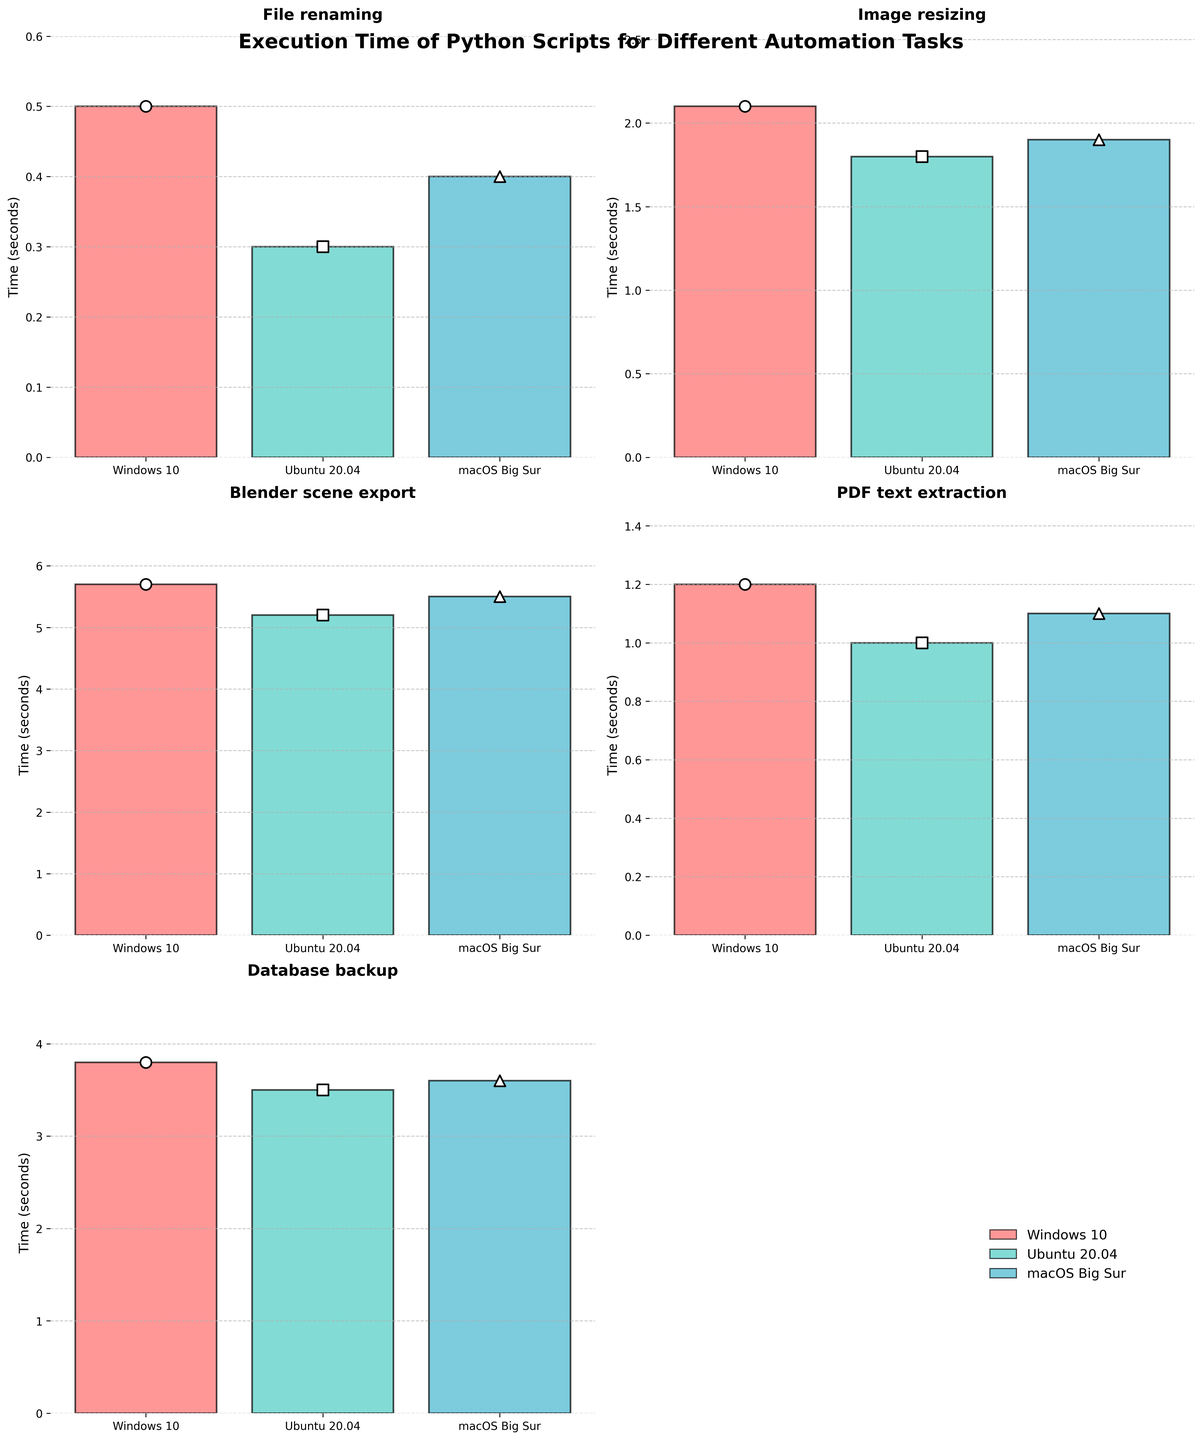Which system has the fastest execution time for the File renaming task? The bar for Ubuntu 20.04 is the shortest in the File renaming subplot, indicating the fastest execution time.
Answer: Ubuntu 20.04 What is the range of execution times for the Blender scene export task? The execution times range from the shortest bar (Ubuntu 20.04 at 5.2 seconds) to the tallest bar (Windows 10 at 5.7 seconds). The range is 5.7 - 5.2 = 0.5 seconds.
Answer: 0.5 seconds How does the execution time for PDF text extraction on macOS Big Sur compare to that on Windows 10? The bar for macOS Big Sur is slightly shorter than the bar for Windows 10 in the PDF text extraction subplot. This indicates macOS Big Sur has a faster execution time.
Answer: Faster What is the difference in execution time between the fastest and slowest system for the Image resizing task? The fastest system is Ubuntu 20.04 with 1.8 seconds, and the slowest system is Windows 10 with 2.1 seconds. The difference is 2.1 - 1.8 = 0.3 seconds.
Answer: 0.3 seconds Which task has the smallest variation in execution times across different systems? The task with the smallest range between the shortest and tallest bars is PDF text extraction, with times between 1.0 and 1.2 seconds.
Answer: PDF text extraction On which system does the Database backup task take the least amount of time? In the Database backup subplot, the bar for Ubuntu 20.04 is the shortest, indicating it has the least execution time.
Answer: Ubuntu 20.04 What are the three distinct colors used in the plot, and what do they represent? The plot uses three distinct colors for the bars, representing different systems: red for Windows 10, green for Ubuntu 20.04, and blue for macOS Big Sur.
Answer: Red, Green, Blue Among the tasks displayed, which one has the longest execution time, and on which system? The tallest bar across all subplots is for the Blender scene export task on Windows 10, which has the longest execution time of 5.7 seconds.
Answer: Blender scene export on Windows 10 What is the average execution time for the Blender scene export task across all systems? Sum the times: 5.7 + 5.2 + 5.5 = 16.4. Then, divide by the number of systems (3). The average time is 16.4 / 3 ≈ 5.47 seconds.
Answer: 5.47 seconds Which system consistently shows the shortest execution times across most tasks? By observing each subplot, Ubuntu 20.04 often has the shortest bars (fastest times) for tasks like File renaming, Image resizing, PDF text extraction, and Database backup.
Answer: Ubuntu 20.04 